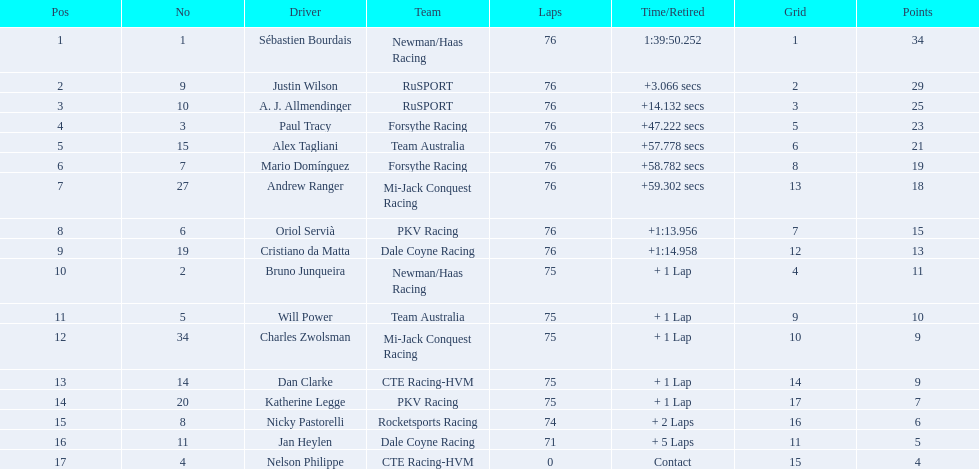In the 2006 tecate grand prix of monterrey, who were the participating drivers? Sébastien Bourdais, Justin Wilson, A. J. Allmendinger, Paul Tracy, Alex Tagliani, Mario Domínguez, Andrew Ranger, Oriol Servià, Cristiano da Matta, Bruno Junqueira, Will Power, Charles Zwolsman, Dan Clarke, Katherine Legge, Nicky Pastorelli, Jan Heylen, Nelson Philippe. Who among them had the same points as another competitor? Charles Zwolsman, Dan Clarke. Who matched charles zwolsman's points total? Dan Clarke. 